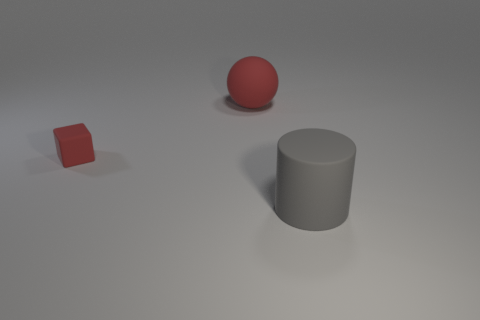Add 1 red spheres. How many objects exist? 4 Add 3 red matte balls. How many red matte balls are left? 4 Add 3 big gray metal things. How many big gray metal things exist? 3 Subtract 0 brown blocks. How many objects are left? 3 Subtract all balls. How many objects are left? 2 Subtract all blue cylinders. Subtract all blue spheres. How many cylinders are left? 1 Subtract all red blocks. How many cyan cylinders are left? 0 Subtract all large red cylinders. Subtract all big red things. How many objects are left? 2 